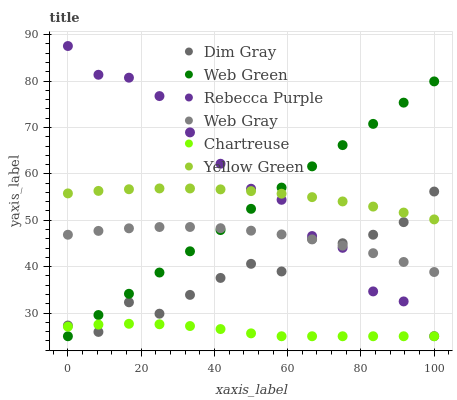Does Chartreuse have the minimum area under the curve?
Answer yes or no. Yes. Does Rebecca Purple have the maximum area under the curve?
Answer yes or no. Yes. Does Yellow Green have the minimum area under the curve?
Answer yes or no. No. Does Yellow Green have the maximum area under the curve?
Answer yes or no. No. Is Web Green the smoothest?
Answer yes or no. Yes. Is Dim Gray the roughest?
Answer yes or no. Yes. Is Yellow Green the smoothest?
Answer yes or no. No. Is Yellow Green the roughest?
Answer yes or no. No. Does Web Green have the lowest value?
Answer yes or no. Yes. Does Yellow Green have the lowest value?
Answer yes or no. No. Does Rebecca Purple have the highest value?
Answer yes or no. Yes. Does Yellow Green have the highest value?
Answer yes or no. No. Is Chartreuse less than Web Gray?
Answer yes or no. Yes. Is Yellow Green greater than Chartreuse?
Answer yes or no. Yes. Does Dim Gray intersect Yellow Green?
Answer yes or no. Yes. Is Dim Gray less than Yellow Green?
Answer yes or no. No. Is Dim Gray greater than Yellow Green?
Answer yes or no. No. Does Chartreuse intersect Web Gray?
Answer yes or no. No. 